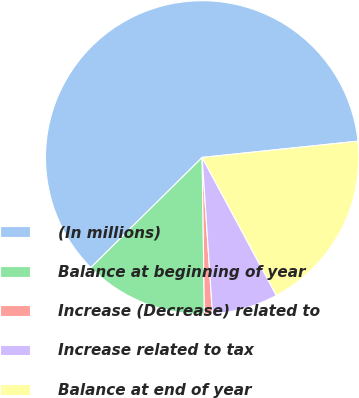Convert chart. <chart><loc_0><loc_0><loc_500><loc_500><pie_chart><fcel>(In millions)<fcel>Balance at beginning of year<fcel>Increase (Decrease) related to<fcel>Increase related to tax<fcel>Balance at end of year<nl><fcel>60.77%<fcel>12.81%<fcel>0.82%<fcel>6.81%<fcel>18.8%<nl></chart> 